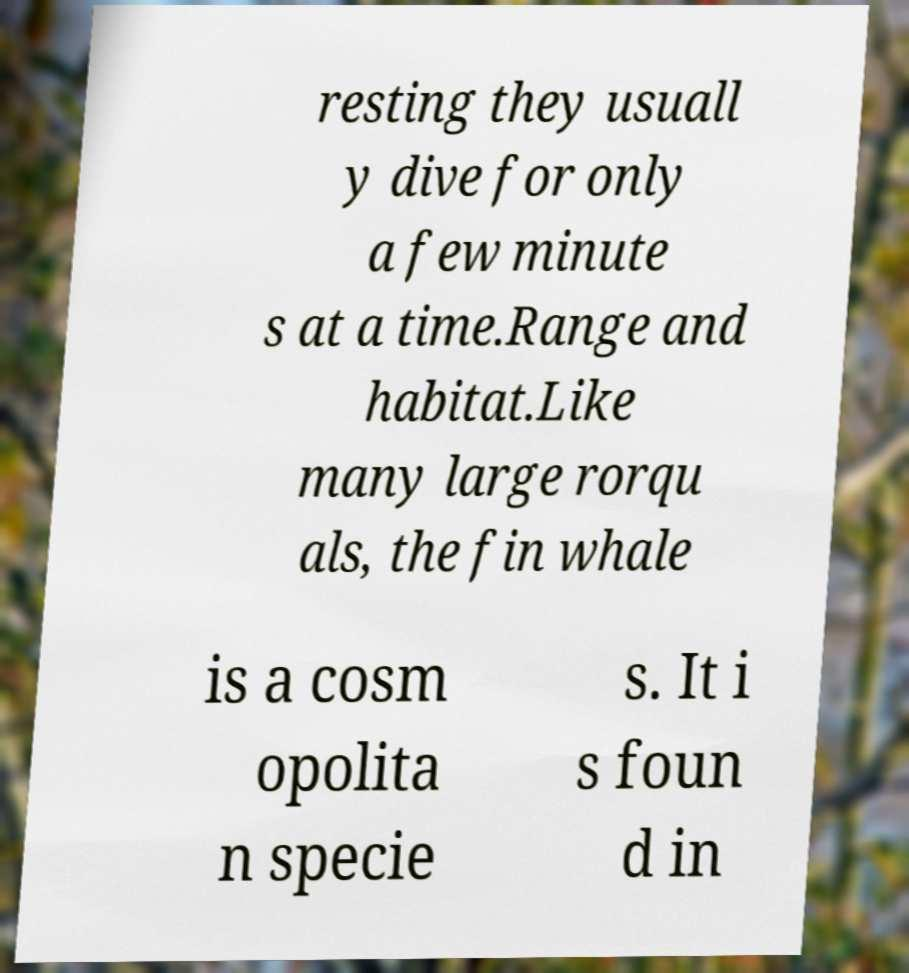Can you accurately transcribe the text from the provided image for me? resting they usuall y dive for only a few minute s at a time.Range and habitat.Like many large rorqu als, the fin whale is a cosm opolita n specie s. It i s foun d in 